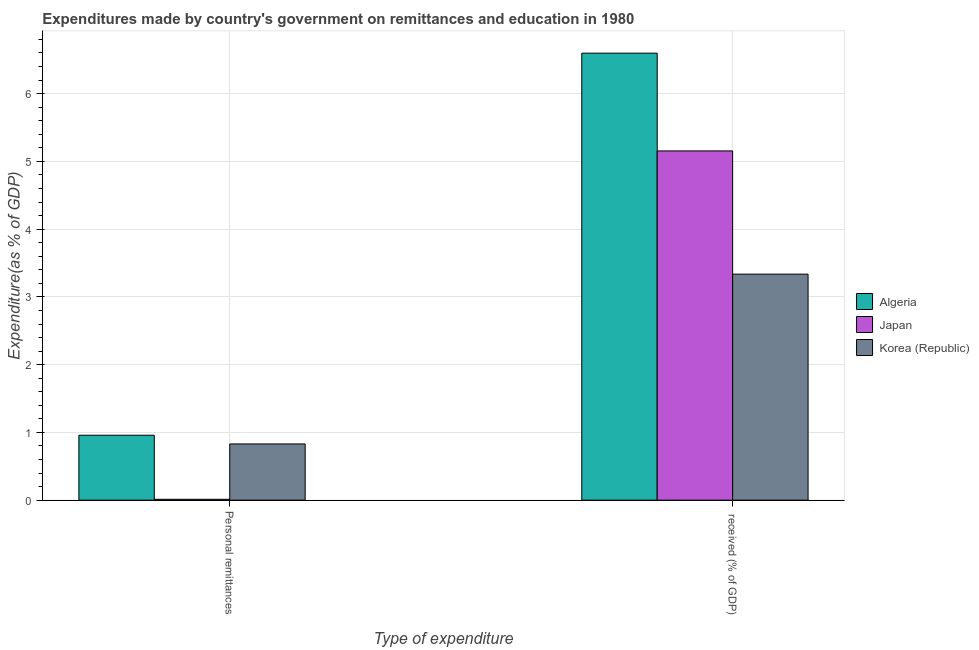How many groups of bars are there?
Your answer should be very brief. 2. Are the number of bars per tick equal to the number of legend labels?
Make the answer very short. Yes. How many bars are there on the 2nd tick from the left?
Your answer should be very brief. 3. What is the label of the 2nd group of bars from the left?
Offer a very short reply.  received (% of GDP). What is the expenditure in personal remittances in Algeria?
Offer a very short reply. 0.96. Across all countries, what is the maximum expenditure in education?
Make the answer very short. 6.6. Across all countries, what is the minimum expenditure in education?
Your answer should be very brief. 3.34. In which country was the expenditure in personal remittances maximum?
Provide a succinct answer. Algeria. In which country was the expenditure in personal remittances minimum?
Make the answer very short. Japan. What is the total expenditure in personal remittances in the graph?
Ensure brevity in your answer.  1.8. What is the difference between the expenditure in education in Japan and that in Korea (Republic)?
Your answer should be very brief. 1.82. What is the difference between the expenditure in personal remittances in Korea (Republic) and the expenditure in education in Japan?
Your answer should be very brief. -4.32. What is the average expenditure in education per country?
Offer a very short reply. 5.03. What is the difference between the expenditure in personal remittances and expenditure in education in Korea (Republic)?
Give a very brief answer. -2.51. What is the ratio of the expenditure in education in Algeria to that in Korea (Republic)?
Ensure brevity in your answer.  1.98. In how many countries, is the expenditure in personal remittances greater than the average expenditure in personal remittances taken over all countries?
Ensure brevity in your answer.  2. What does the 3rd bar from the left in Personal remittances represents?
Provide a succinct answer. Korea (Republic). What does the 2nd bar from the right in Personal remittances represents?
Your response must be concise. Japan. How many countries are there in the graph?
Provide a succinct answer. 3. Does the graph contain any zero values?
Your response must be concise. No. How many legend labels are there?
Your answer should be compact. 3. How are the legend labels stacked?
Your answer should be compact. Vertical. What is the title of the graph?
Offer a terse response. Expenditures made by country's government on remittances and education in 1980. What is the label or title of the X-axis?
Provide a short and direct response. Type of expenditure. What is the label or title of the Y-axis?
Offer a very short reply. Expenditure(as % of GDP). What is the Expenditure(as % of GDP) in Algeria in Personal remittances?
Provide a short and direct response. 0.96. What is the Expenditure(as % of GDP) of Japan in Personal remittances?
Provide a short and direct response. 0.01. What is the Expenditure(as % of GDP) in Korea (Republic) in Personal remittances?
Make the answer very short. 0.83. What is the Expenditure(as % of GDP) in Algeria in  received (% of GDP)?
Ensure brevity in your answer.  6.6. What is the Expenditure(as % of GDP) of Japan in  received (% of GDP)?
Your answer should be compact. 5.15. What is the Expenditure(as % of GDP) in Korea (Republic) in  received (% of GDP)?
Your answer should be very brief. 3.34. Across all Type of expenditure, what is the maximum Expenditure(as % of GDP) of Algeria?
Your response must be concise. 6.6. Across all Type of expenditure, what is the maximum Expenditure(as % of GDP) of Japan?
Offer a terse response. 5.15. Across all Type of expenditure, what is the maximum Expenditure(as % of GDP) of Korea (Republic)?
Provide a short and direct response. 3.34. Across all Type of expenditure, what is the minimum Expenditure(as % of GDP) of Algeria?
Provide a succinct answer. 0.96. Across all Type of expenditure, what is the minimum Expenditure(as % of GDP) of Japan?
Make the answer very short. 0.01. Across all Type of expenditure, what is the minimum Expenditure(as % of GDP) of Korea (Republic)?
Your answer should be compact. 0.83. What is the total Expenditure(as % of GDP) in Algeria in the graph?
Your answer should be very brief. 7.56. What is the total Expenditure(as % of GDP) of Japan in the graph?
Your answer should be very brief. 5.17. What is the total Expenditure(as % of GDP) of Korea (Republic) in the graph?
Provide a succinct answer. 4.17. What is the difference between the Expenditure(as % of GDP) of Algeria in Personal remittances and that in  received (% of GDP)?
Provide a short and direct response. -5.64. What is the difference between the Expenditure(as % of GDP) of Japan in Personal remittances and that in  received (% of GDP)?
Offer a terse response. -5.14. What is the difference between the Expenditure(as % of GDP) of Korea (Republic) in Personal remittances and that in  received (% of GDP)?
Offer a terse response. -2.51. What is the difference between the Expenditure(as % of GDP) in Algeria in Personal remittances and the Expenditure(as % of GDP) in Japan in  received (% of GDP)?
Offer a very short reply. -4.2. What is the difference between the Expenditure(as % of GDP) of Algeria in Personal remittances and the Expenditure(as % of GDP) of Korea (Republic) in  received (% of GDP)?
Make the answer very short. -2.38. What is the difference between the Expenditure(as % of GDP) in Japan in Personal remittances and the Expenditure(as % of GDP) in Korea (Republic) in  received (% of GDP)?
Offer a very short reply. -3.32. What is the average Expenditure(as % of GDP) in Algeria per Type of expenditure?
Offer a terse response. 3.78. What is the average Expenditure(as % of GDP) of Japan per Type of expenditure?
Make the answer very short. 2.58. What is the average Expenditure(as % of GDP) in Korea (Republic) per Type of expenditure?
Offer a very short reply. 2.08. What is the difference between the Expenditure(as % of GDP) in Algeria and Expenditure(as % of GDP) in Japan in Personal remittances?
Offer a terse response. 0.95. What is the difference between the Expenditure(as % of GDP) of Algeria and Expenditure(as % of GDP) of Korea (Republic) in Personal remittances?
Offer a terse response. 0.13. What is the difference between the Expenditure(as % of GDP) of Japan and Expenditure(as % of GDP) of Korea (Republic) in Personal remittances?
Make the answer very short. -0.82. What is the difference between the Expenditure(as % of GDP) of Algeria and Expenditure(as % of GDP) of Japan in  received (% of GDP)?
Provide a succinct answer. 1.44. What is the difference between the Expenditure(as % of GDP) in Algeria and Expenditure(as % of GDP) in Korea (Republic) in  received (% of GDP)?
Offer a terse response. 3.26. What is the difference between the Expenditure(as % of GDP) of Japan and Expenditure(as % of GDP) of Korea (Republic) in  received (% of GDP)?
Ensure brevity in your answer.  1.82. What is the ratio of the Expenditure(as % of GDP) of Algeria in Personal remittances to that in  received (% of GDP)?
Ensure brevity in your answer.  0.15. What is the ratio of the Expenditure(as % of GDP) in Japan in Personal remittances to that in  received (% of GDP)?
Give a very brief answer. 0. What is the ratio of the Expenditure(as % of GDP) of Korea (Republic) in Personal remittances to that in  received (% of GDP)?
Keep it short and to the point. 0.25. What is the difference between the highest and the second highest Expenditure(as % of GDP) of Algeria?
Provide a succinct answer. 5.64. What is the difference between the highest and the second highest Expenditure(as % of GDP) in Japan?
Offer a terse response. 5.14. What is the difference between the highest and the second highest Expenditure(as % of GDP) in Korea (Republic)?
Provide a succinct answer. 2.51. What is the difference between the highest and the lowest Expenditure(as % of GDP) of Algeria?
Ensure brevity in your answer.  5.64. What is the difference between the highest and the lowest Expenditure(as % of GDP) in Japan?
Provide a succinct answer. 5.14. What is the difference between the highest and the lowest Expenditure(as % of GDP) of Korea (Republic)?
Your response must be concise. 2.51. 